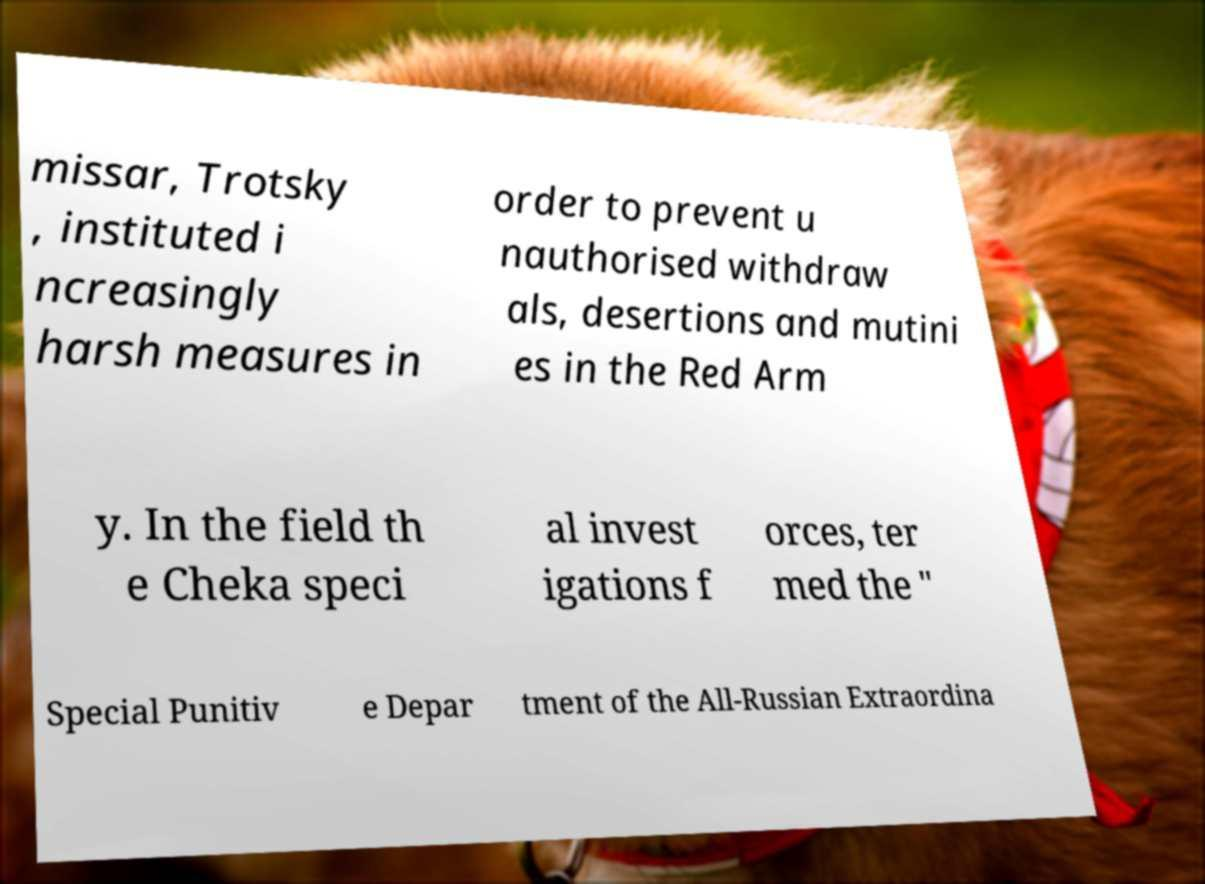There's text embedded in this image that I need extracted. Can you transcribe it verbatim? missar, Trotsky , instituted i ncreasingly harsh measures in order to prevent u nauthorised withdraw als, desertions and mutini es in the Red Arm y. In the field th e Cheka speci al invest igations f orces, ter med the " Special Punitiv e Depar tment of the All-Russian Extraordina 